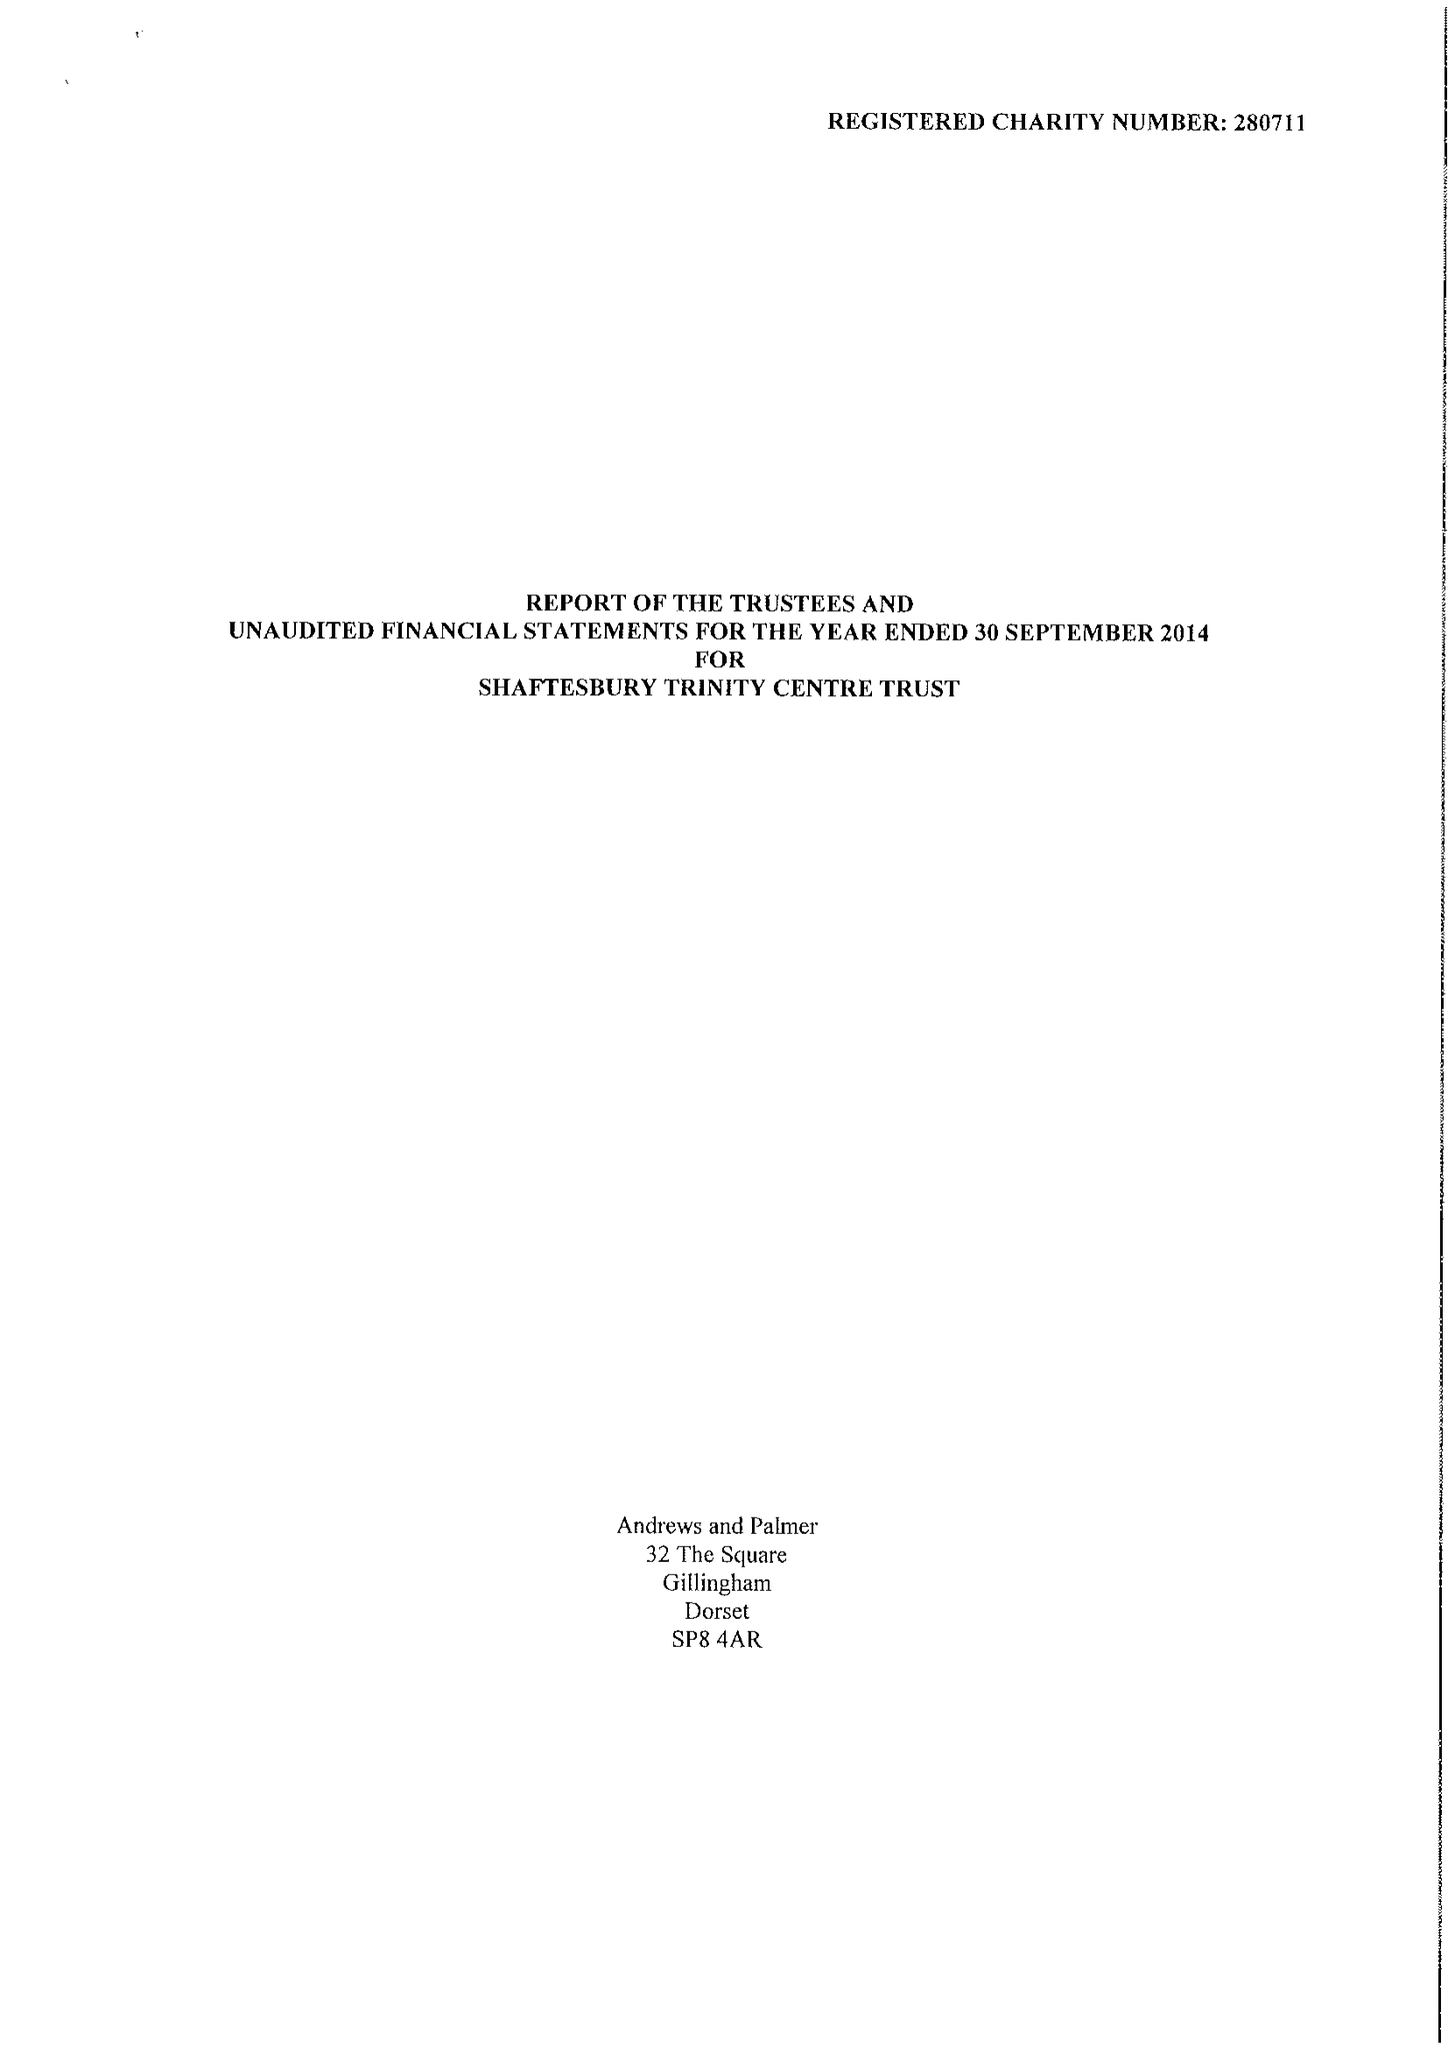What is the value for the address__street_line?
Answer the question using a single word or phrase. None 